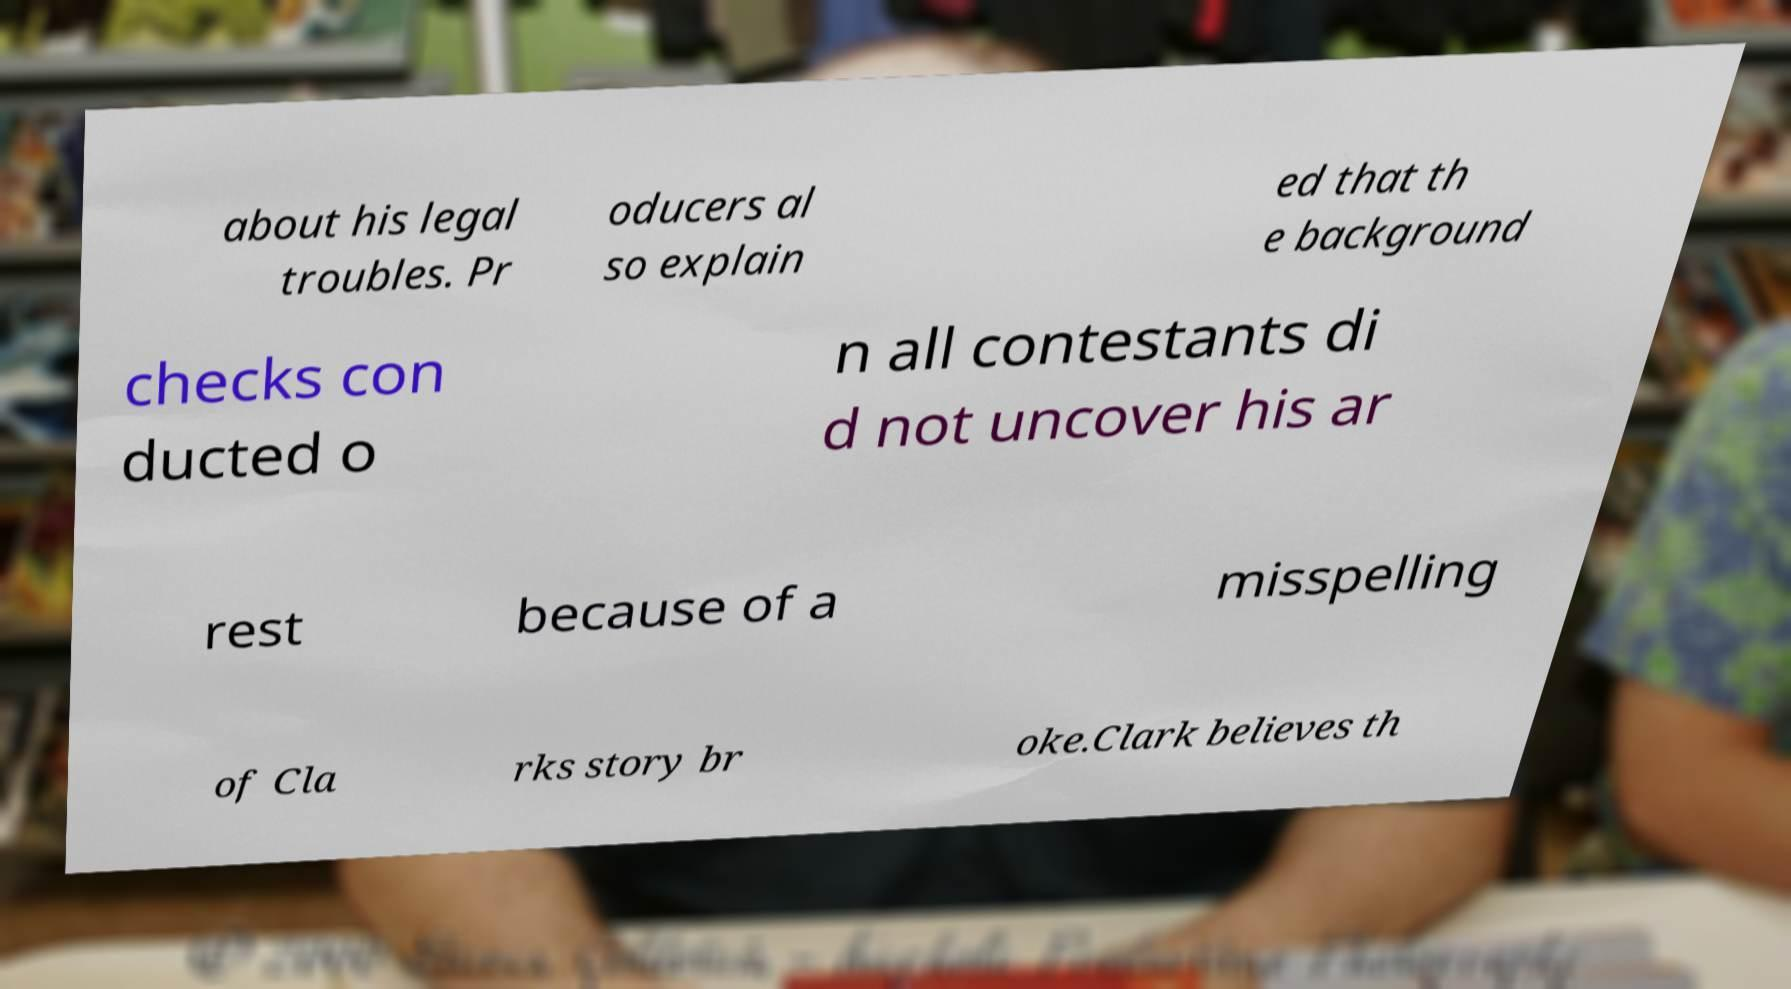There's text embedded in this image that I need extracted. Can you transcribe it verbatim? about his legal troubles. Pr oducers al so explain ed that th e background checks con ducted o n all contestants di d not uncover his ar rest because of a misspelling of Cla rks story br oke.Clark believes th 